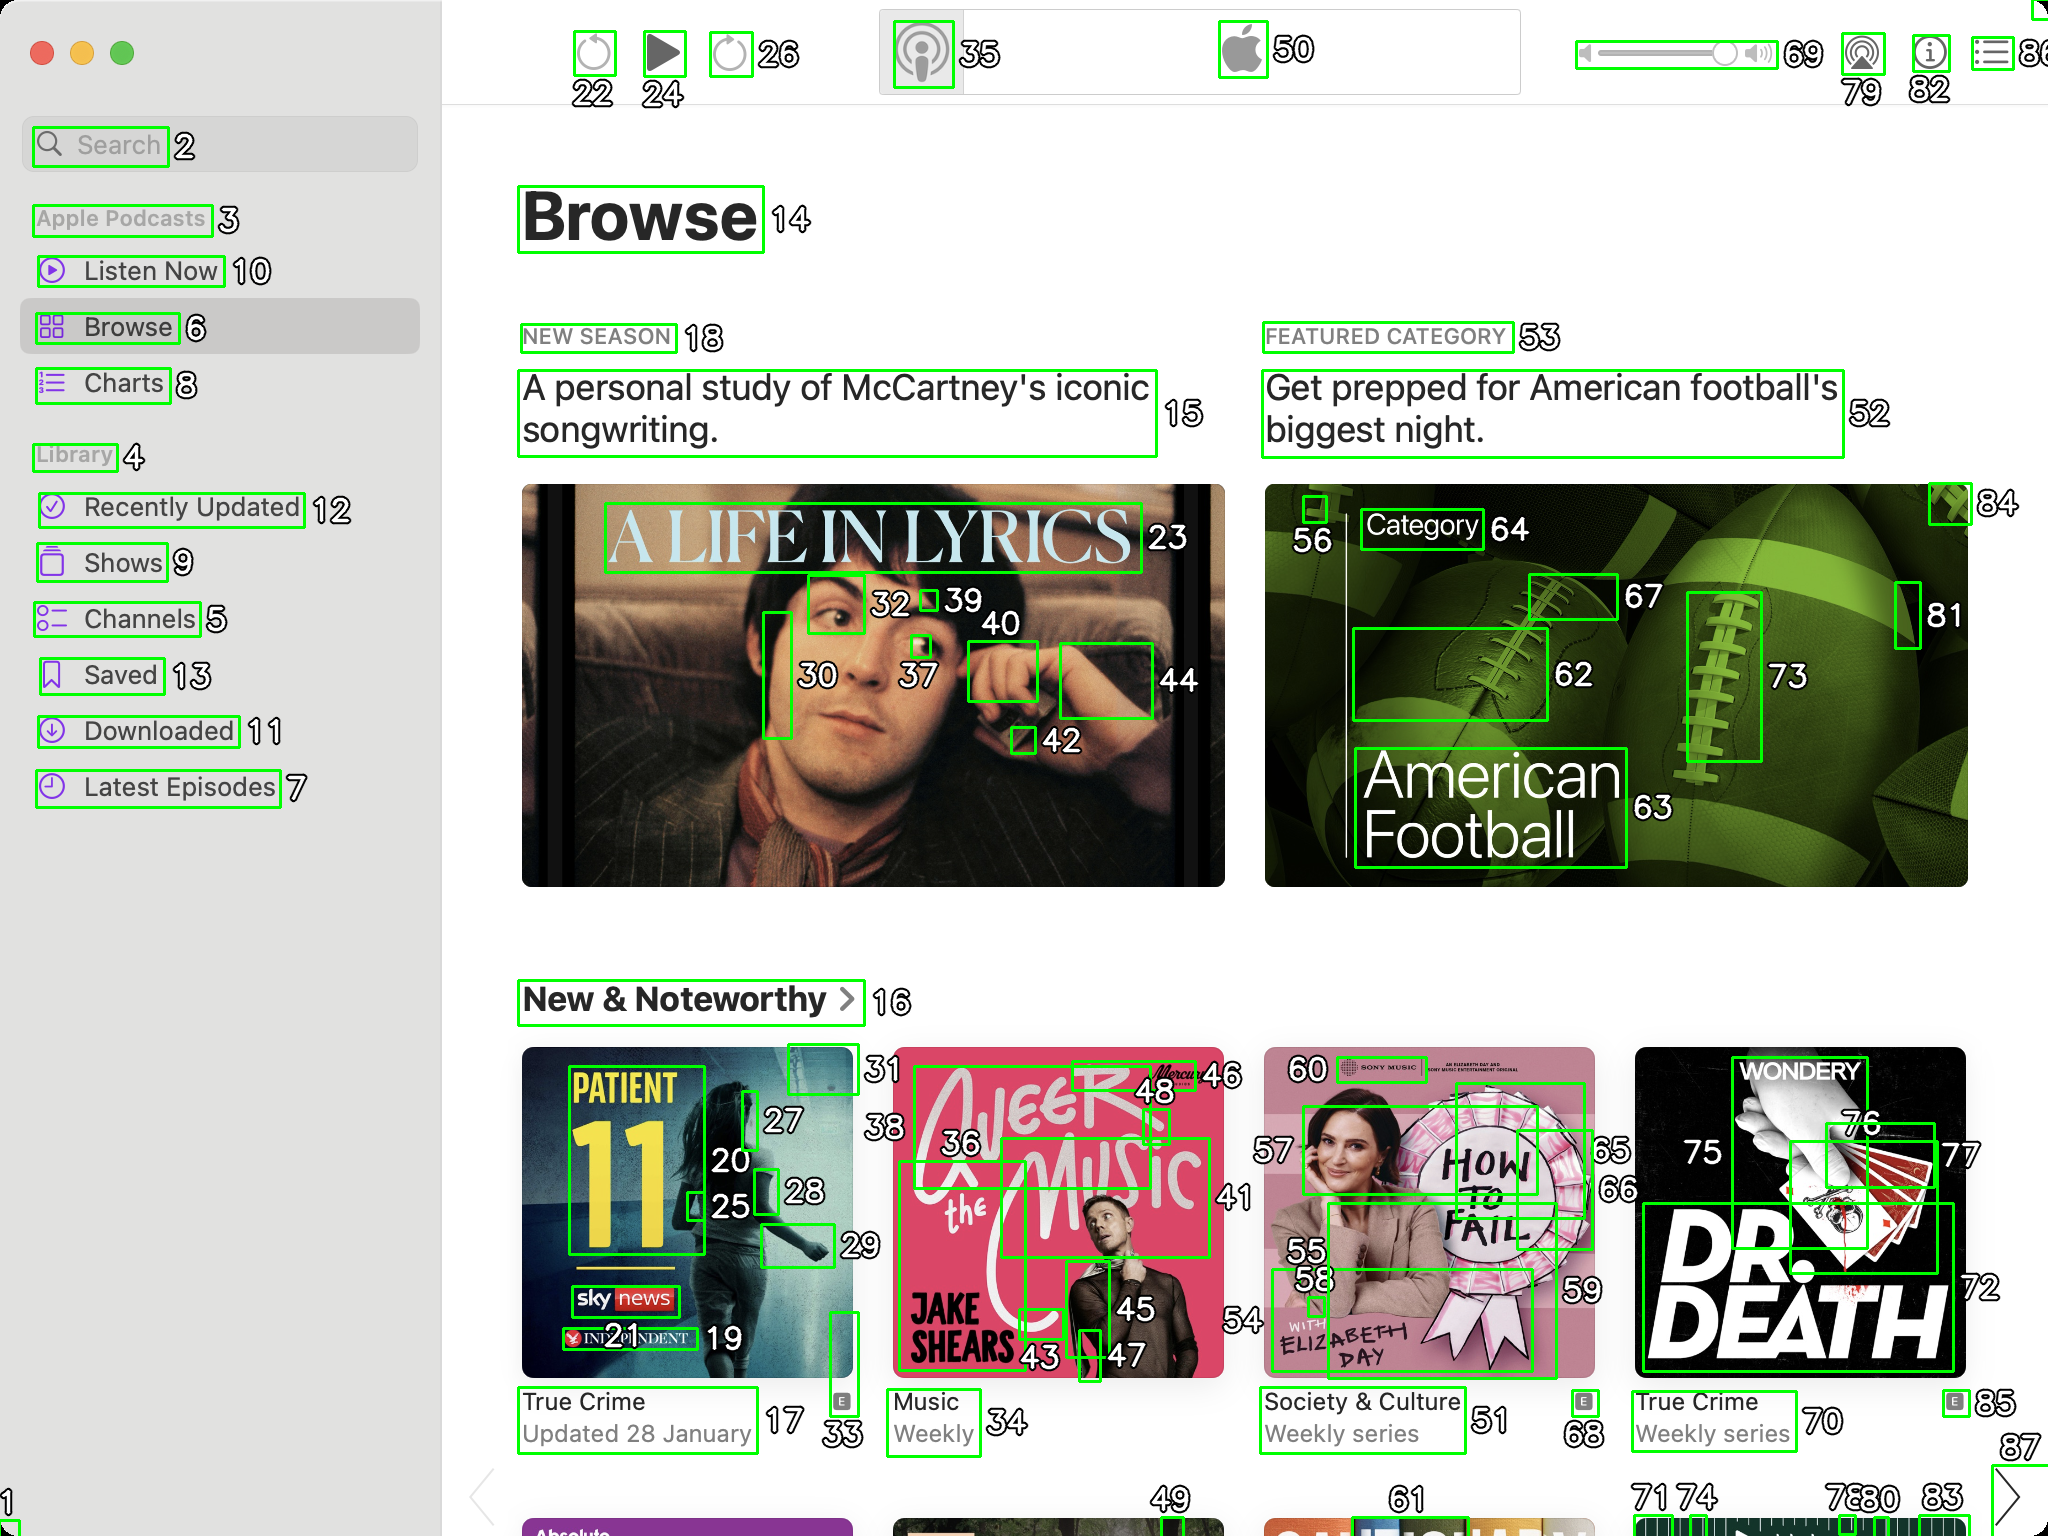You are an AI designed for image processing and segmentation analysis, particularly skilled in merging segmented regions of an image to improve accuracy and readability.

**Task Description:**
Your task is to address a user's concern with a UI screenshot of the Apple Podcasts application on MacOS. The screenshot contains multiple green boxes, each representing a UI element, with a unique white number outlined in black ranging from 1 to 88. Due to segmentation issues, some boxes that belong to the same image are divided unnaturally.

**Objective:**
Merge these segmented areas that correspond to a single UI element to create a coherent representation. The final output should be in JSON format, where each key-value pair represents the merged areas.

**Example JSON Output:**
If boxes with numbers 1, 2, and 3 should belong to the same UI element, the JSON output should be:

```json
{
    "Image A Life In Lyrics": [1, 2, 3]
}
```

**Instructions:**

- **Identify Segmented Regions:** Analyze the screenshot to identify which green boxes belong to the same UI element.
- **Merge Regions:** Group the numbers of these boxes together to represent a single UI element.
- **Output Format:** Produce the output in JSON format, with each key representing a UI element and each value being a list of the numbers of the merged boxes. Don't include in the result UI elements that consist of one box.

**Primary Objective:**
Ensure the accuracy of the merged regions based on the user's supplied image information, maintaining the integrity and structure of the UI elements in the Apple Podcasts application on MacOS. ```json
{
    "Browse": [14],
    "New Season": [18],
    "A Life in Lyrics": [23, 30, 32, 37, 39, 42, 44],
    "Featured Category": [53],
    "Get prepped for American football's biggest night.": [52],
    "Category": [64],
    "American Football": [62, 63, 67, 72, 73, 76],
    "New & Noteworthy": [16],
    "Patient 11": [27, 20, 25, 28, 29],
    "Queer the Music": [36, 46, 41, 45, 43, 47],
    "Jake Shears": [54, 58],
    "Society & Culture": [51, 55, 59],
    "True Crime": [68, 70, 71, 74],
    "Dr. Death": [75, 81, 85, 87]
}
``` 